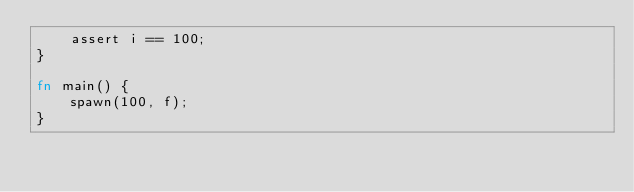<code> <loc_0><loc_0><loc_500><loc_500><_Rust_>    assert i == 100;
}

fn main() {
    spawn(100, f);
}</code> 